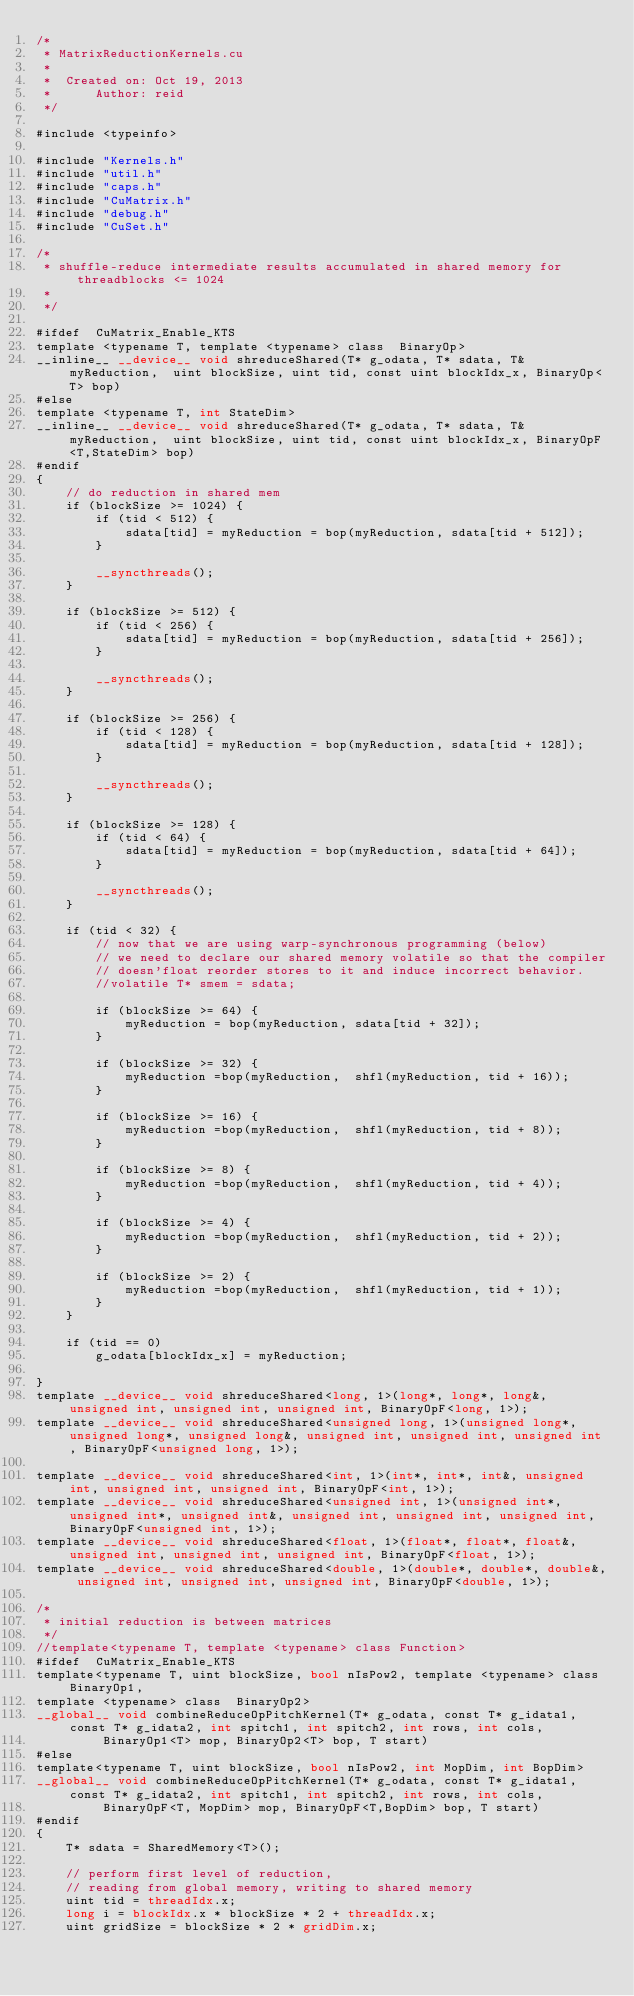Convert code to text. <code><loc_0><loc_0><loc_500><loc_500><_Cuda_>/*
 * MatrixReductionKernels.cu
 *
 *  Created on: Oct 19, 2013
 *      Author: reid
 */

#include <typeinfo>

#include "Kernels.h"
#include "util.h"
#include "caps.h"
#include "CuMatrix.h"
#include "debug.h"
#include "CuSet.h"

/*
 * shuffle-reduce intermediate results accumulated in shared memory for threadblocks <= 1024
 *
 */

#ifdef  CuMatrix_Enable_KTS
template <typename T, template <typename> class  BinaryOp>
__inline__ __device__ void shreduceShared(T* g_odata, T* sdata, T& myReduction,  uint blockSize, uint tid, const uint blockIdx_x, BinaryOp<T> bop)
#else
template <typename T, int StateDim>
__inline__ __device__ void shreduceShared(T* g_odata, T* sdata, T& myReduction,  uint blockSize, uint tid, const uint blockIdx_x, BinaryOpF<T,StateDim> bop)
#endif
{
	// do reduction in shared mem
	if (blockSize >= 1024) {
		if (tid < 512) {
			sdata[tid] = myReduction = bop(myReduction, sdata[tid + 512]);
		}

		__syncthreads();
	}

	if (blockSize >= 512) {
		if (tid < 256) {
			sdata[tid] = myReduction = bop(myReduction, sdata[tid + 256]);
		}

		__syncthreads();
	}

	if (blockSize >= 256) {
		if (tid < 128) {
			sdata[tid] = myReduction = bop(myReduction, sdata[tid + 128]);
		}

		__syncthreads();
	}

	if (blockSize >= 128) {
		if (tid < 64) {
			sdata[tid] = myReduction = bop(myReduction, sdata[tid + 64]);
		}

		__syncthreads();
	}

	if (tid < 32) {
		// now that we are using warp-synchronous programming (below)
		// we need to declare our shared memory volatile so that the compiler
		// doesn'float reorder stores to it and induce incorrect behavior.
		//volatile T* smem = sdata;

		if (blockSize >= 64) {
			myReduction = bop(myReduction, sdata[tid + 32]);
		}

		if (blockSize >= 32) {
			myReduction =bop(myReduction,  shfl(myReduction, tid + 16));
		}

		if (blockSize >= 16) {
			myReduction =bop(myReduction,  shfl(myReduction, tid + 8));
		}

		if (blockSize >= 8) {
			myReduction =bop(myReduction,  shfl(myReduction, tid + 4));
		}

		if (blockSize >= 4) {
			myReduction =bop(myReduction,  shfl(myReduction, tid + 2));
		}

		if (blockSize >= 2) {
			myReduction =bop(myReduction,  shfl(myReduction, tid + 1));
		}
	}

	if (tid == 0)
		g_odata[blockIdx_x] = myReduction;

}
template __device__ void shreduceShared<long, 1>(long*, long*, long&, unsigned int, unsigned int, unsigned int, BinaryOpF<long, 1>);
template __device__ void shreduceShared<unsigned long, 1>(unsigned long*, unsigned long*, unsigned long&, unsigned int, unsigned int, unsigned int, BinaryOpF<unsigned long, 1>);

template __device__ void shreduceShared<int, 1>(int*, int*, int&, unsigned int, unsigned int, unsigned int, BinaryOpF<int, 1>);
template __device__ void shreduceShared<unsigned int, 1>(unsigned int*, unsigned int*, unsigned int&, unsigned int, unsigned int, unsigned int, BinaryOpF<unsigned int, 1>);
template __device__ void shreduceShared<float, 1>(float*, float*, float&, unsigned int, unsigned int, unsigned int, BinaryOpF<float, 1>);
template __device__ void shreduceShared<double, 1>(double*, double*, double&, unsigned int, unsigned int, unsigned int, BinaryOpF<double, 1>);

/*
 * initial reduction is between matrices
 */
//template<typename T, template <typename> class Function>
#ifdef  CuMatrix_Enable_KTS
template<typename T, uint blockSize, bool nIsPow2, template <typename> class BinaryOp1,
template <typename> class  BinaryOp2>
__global__ void combineReduceOpPitchKernel(T* g_odata, const T* g_idata1, const T* g_idata2, int spitch1, int spitch2, int rows, int cols,
		 BinaryOp1<T> mop, BinaryOp2<T> bop, T start)
#else
template<typename T, uint blockSize, bool nIsPow2, int MopDim, int BopDim>
__global__ void combineReduceOpPitchKernel(T* g_odata, const T* g_idata1, const T* g_idata2, int spitch1, int spitch2, int rows, int cols,
		 BinaryOpF<T, MopDim> mop, BinaryOpF<T,BopDim> bop, T start)
#endif
{
	T* sdata = SharedMemory<T>();

	// perform first level of reduction,
	// reading from global memory, writing to shared memory
	uint tid = threadIdx.x;
	long i = blockIdx.x * blockSize * 2 + threadIdx.x;
	uint gridSize = blockSize * 2 * gridDim.x;</code> 